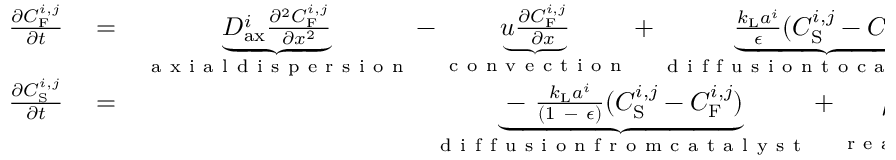<formula> <loc_0><loc_0><loc_500><loc_500>\begin{array} { r l r } { \frac { \partial C _ { F } ^ { i , j } } { \partial t } } & = } & { \underbrace { D _ { a x } ^ { i } \frac { \partial ^ { 2 } C _ { F } ^ { i , j } } { \partial x ^ { 2 } } } _ { a x i a l d i s p e r s i o n } - \underbrace { u \frac { \partial C _ { F } ^ { i , j } } { \partial x } } _ { c o n v e c t i o n } + \underbrace { \frac { k _ { L } a ^ { i } } { \epsilon } ( C _ { S } ^ { i , j } - C _ { F } ^ { i , j } ) } _ { d i f f u s i o n t o c a t a l y s t } , } \\ { \frac { \partial C _ { S } ^ { i , j } } { \partial t } } & = } & { \underbrace { - \frac { k _ { L } a ^ { i } } { ( 1 - \epsilon ) } ( C _ { S } ^ { i , j } - C _ { F } ^ { i , j } ) } _ { d i f f u s i o n f r o m c a t a l y s t } + \underbrace { \rho _ { B } \frac { v ^ { i } } { [ E ] } } _ { r e a c t i o n } \ , } \end{array}</formula> 